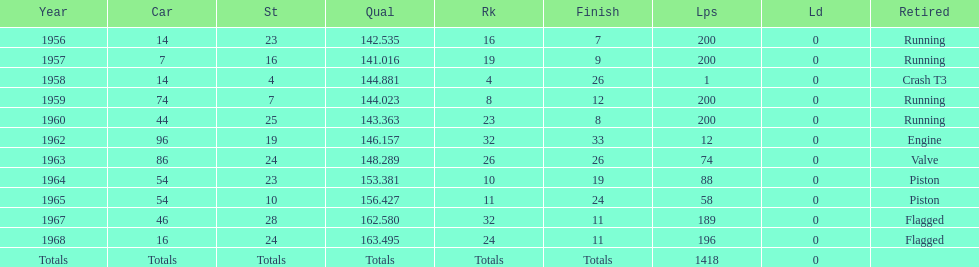What was the length of time bob veith had the number 54 car in indy 500? 2 years. 